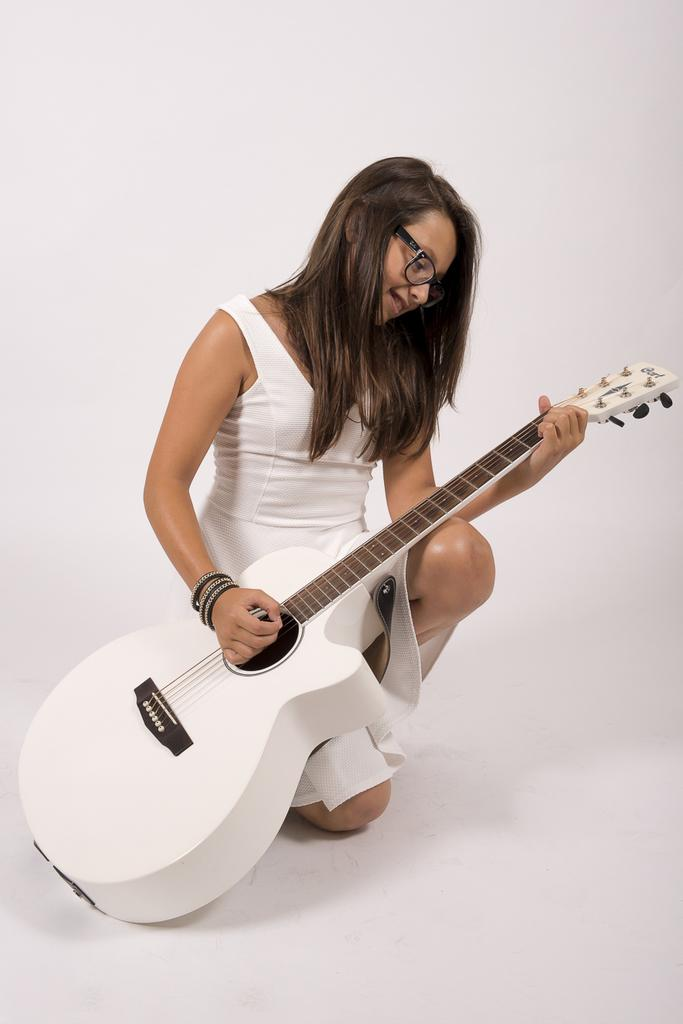Who is present in the image? There is a woman in the image. What is the woman wearing? The woman is wearing a white dress. What object is the woman holding? The woman is holding a white guitar. What color is the background of the image? The background of the image is a white wall. What type of celery is the woman eating in the image? There is no celery present in the image; the woman is holding a white guitar. What religious symbol can be seen in the image? There is no religious symbol present in the image; the woman is wearing a white dress and holding a white guitar in front of a white wall. 